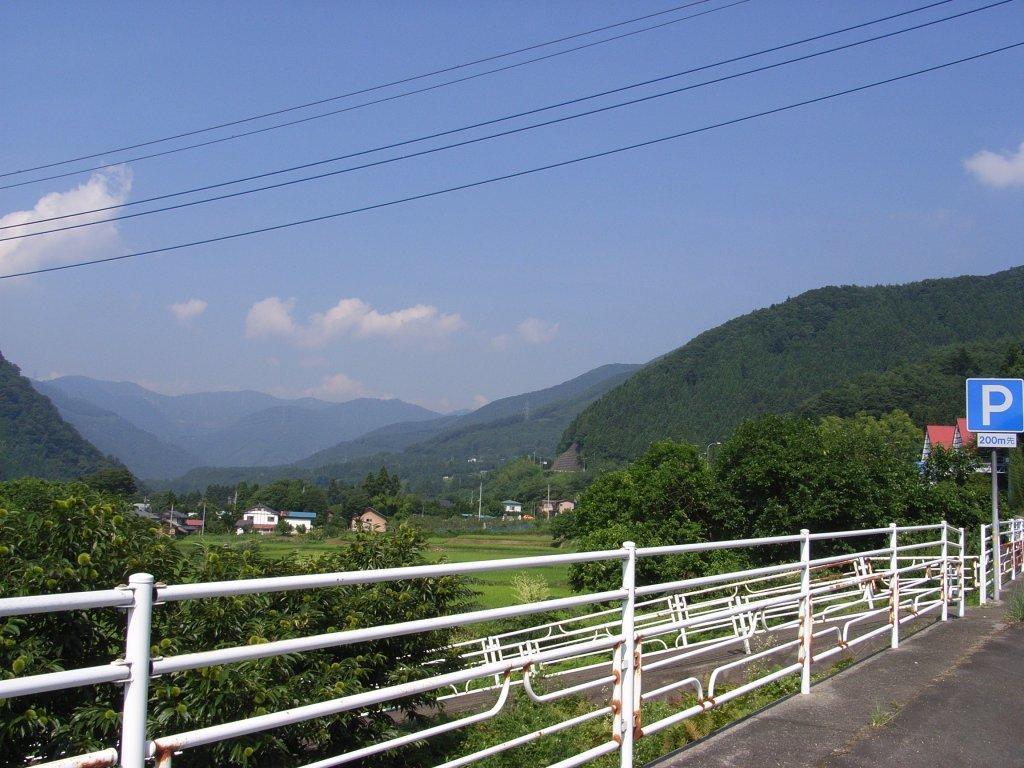How would you summarize this image in a sentence or two? In this picture we can observe a road and a white color railing. There are some trees and houses. In the background we can observe hills and a sky with some clouds. 